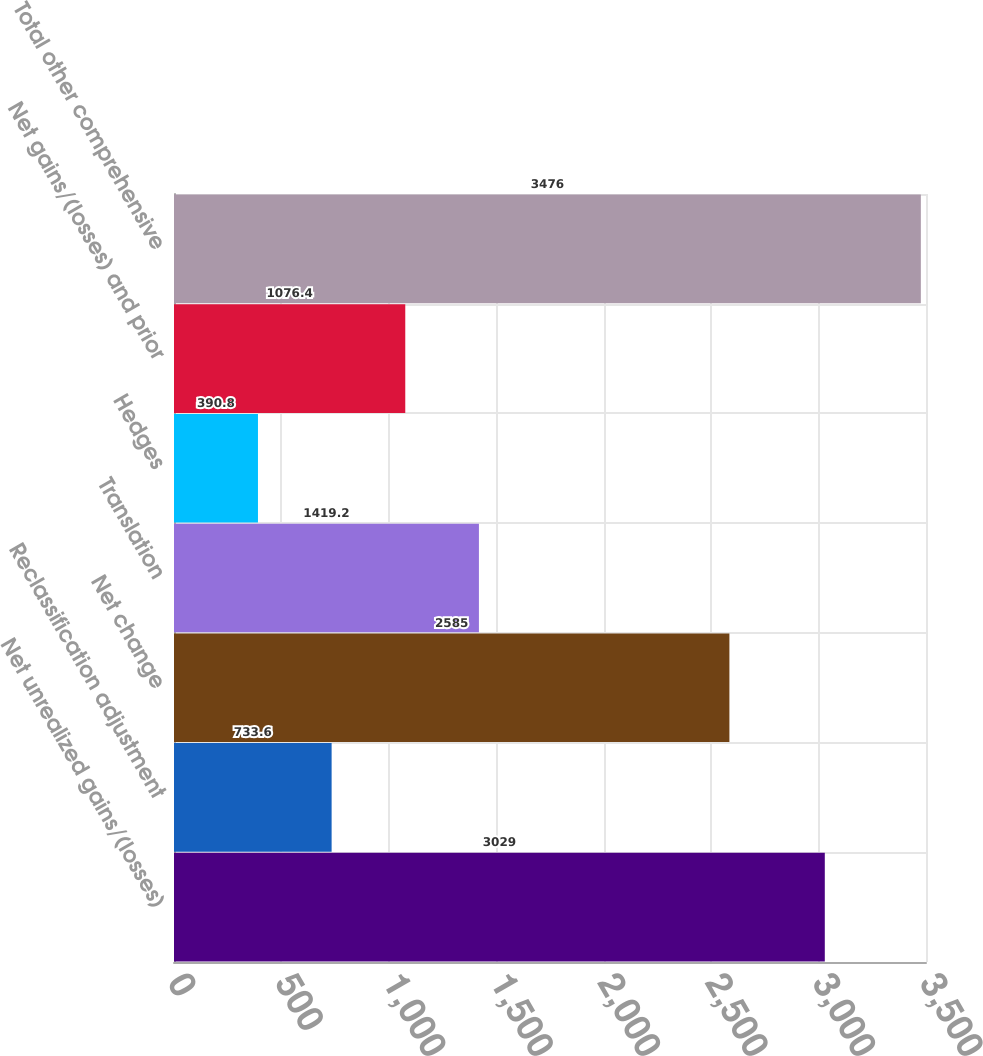Convert chart. <chart><loc_0><loc_0><loc_500><loc_500><bar_chart><fcel>Net unrealized gains/(losses)<fcel>Reclassification adjustment<fcel>Net change<fcel>Translation<fcel>Hedges<fcel>Net gains/(losses) and prior<fcel>Total other comprehensive<nl><fcel>3029<fcel>733.6<fcel>2585<fcel>1419.2<fcel>390.8<fcel>1076.4<fcel>3476<nl></chart> 